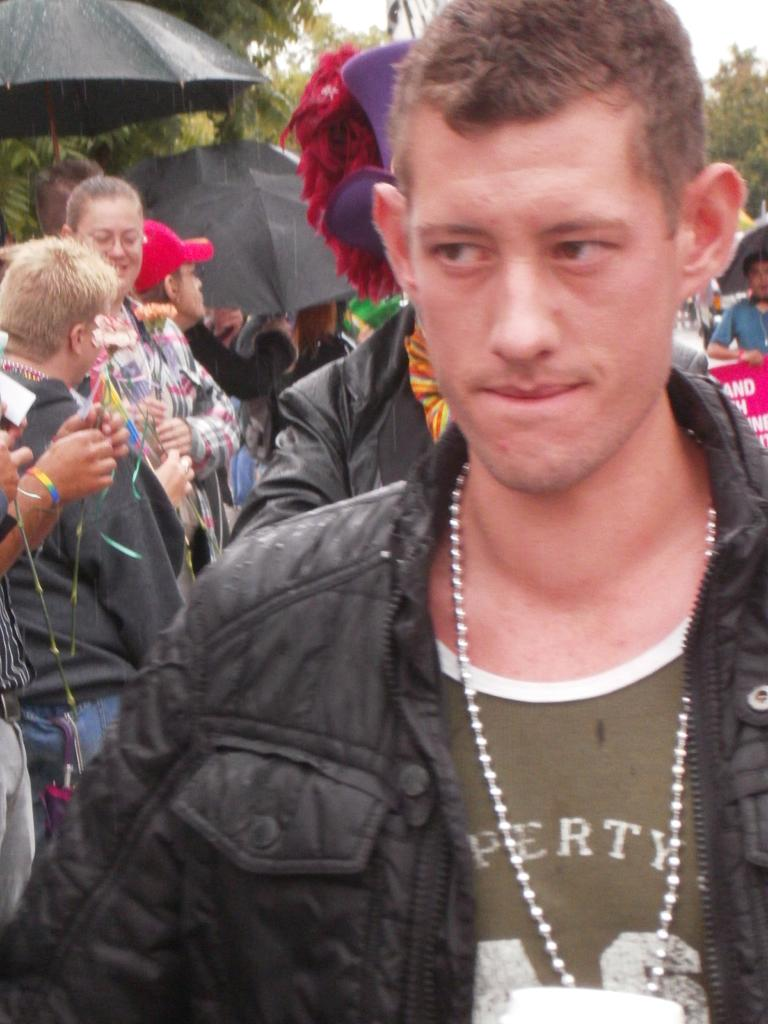What is the main subject of the image? The main subject of the image is a group of people. What are the people in the image doing? The people are standing. What are the people wearing in the image? The people are wearing clothes. What can be seen in the top left corner of the image? There are umbrellas in the top left corner of the image. What type of receipt can be seen in the image? There is no receipt present in the image. What material are the umbrellas made of in the image? The material of the umbrellas cannot be determined from the image. 